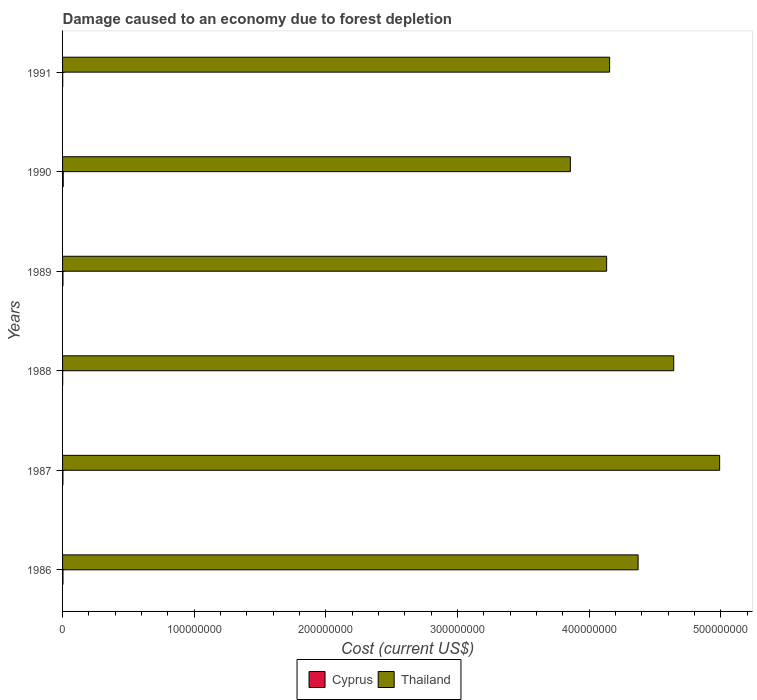How many different coloured bars are there?
Keep it short and to the point. 2. Are the number of bars per tick equal to the number of legend labels?
Give a very brief answer. Yes. What is the label of the 1st group of bars from the top?
Offer a terse response. 1991. What is the cost of damage caused due to forest depletion in Thailand in 1988?
Your answer should be compact. 4.64e+08. Across all years, what is the maximum cost of damage caused due to forest depletion in Cyprus?
Provide a succinct answer. 5.16e+05. Across all years, what is the minimum cost of damage caused due to forest depletion in Thailand?
Give a very brief answer. 3.86e+08. What is the total cost of damage caused due to forest depletion in Cyprus in the graph?
Keep it short and to the point. 1.59e+06. What is the difference between the cost of damage caused due to forest depletion in Thailand in 1989 and that in 1990?
Offer a terse response. 2.75e+07. What is the difference between the cost of damage caused due to forest depletion in Cyprus in 1990 and the cost of damage caused due to forest depletion in Thailand in 1989?
Provide a succinct answer. -4.13e+08. What is the average cost of damage caused due to forest depletion in Thailand per year?
Your answer should be compact. 4.36e+08. In the year 1990, what is the difference between the cost of damage caused due to forest depletion in Thailand and cost of damage caused due to forest depletion in Cyprus?
Your response must be concise. 3.85e+08. What is the ratio of the cost of damage caused due to forest depletion in Cyprus in 1989 to that in 1991?
Your answer should be very brief. 3.01. Is the cost of damage caused due to forest depletion in Cyprus in 1987 less than that in 1988?
Offer a very short reply. No. What is the difference between the highest and the second highest cost of damage caused due to forest depletion in Cyprus?
Make the answer very short. 2.01e+05. What is the difference between the highest and the lowest cost of damage caused due to forest depletion in Cyprus?
Offer a very short reply. 4.30e+05. In how many years, is the cost of damage caused due to forest depletion in Cyprus greater than the average cost of damage caused due to forest depletion in Cyprus taken over all years?
Offer a terse response. 4. What does the 2nd bar from the top in 1986 represents?
Ensure brevity in your answer.  Cyprus. What does the 2nd bar from the bottom in 1987 represents?
Your response must be concise. Thailand. How many bars are there?
Provide a succinct answer. 12. Are the values on the major ticks of X-axis written in scientific E-notation?
Offer a terse response. No. Does the graph contain any zero values?
Keep it short and to the point. No. How many legend labels are there?
Provide a succinct answer. 2. How are the legend labels stacked?
Make the answer very short. Horizontal. What is the title of the graph?
Your answer should be very brief. Damage caused to an economy due to forest depletion. What is the label or title of the X-axis?
Ensure brevity in your answer.  Cost (current US$). What is the Cost (current US$) in Cyprus in 1986?
Ensure brevity in your answer.  3.14e+05. What is the Cost (current US$) of Thailand in 1986?
Provide a succinct answer. 4.37e+08. What is the Cost (current US$) in Cyprus in 1987?
Provide a succinct answer. 2.67e+05. What is the Cost (current US$) in Thailand in 1987?
Your answer should be very brief. 4.99e+08. What is the Cost (current US$) of Cyprus in 1988?
Your answer should be compact. 8.51e+04. What is the Cost (current US$) of Thailand in 1988?
Offer a very short reply. 4.64e+08. What is the Cost (current US$) in Cyprus in 1989?
Make the answer very short. 3.10e+05. What is the Cost (current US$) of Thailand in 1989?
Provide a short and direct response. 4.13e+08. What is the Cost (current US$) in Cyprus in 1990?
Your answer should be very brief. 5.16e+05. What is the Cost (current US$) in Thailand in 1990?
Your response must be concise. 3.86e+08. What is the Cost (current US$) of Cyprus in 1991?
Your answer should be compact. 1.03e+05. What is the Cost (current US$) of Thailand in 1991?
Ensure brevity in your answer.  4.16e+08. Across all years, what is the maximum Cost (current US$) in Cyprus?
Give a very brief answer. 5.16e+05. Across all years, what is the maximum Cost (current US$) of Thailand?
Make the answer very short. 4.99e+08. Across all years, what is the minimum Cost (current US$) in Cyprus?
Offer a very short reply. 8.51e+04. Across all years, what is the minimum Cost (current US$) of Thailand?
Ensure brevity in your answer.  3.86e+08. What is the total Cost (current US$) in Cyprus in the graph?
Offer a terse response. 1.59e+06. What is the total Cost (current US$) of Thailand in the graph?
Make the answer very short. 2.62e+09. What is the difference between the Cost (current US$) of Cyprus in 1986 and that in 1987?
Offer a very short reply. 4.73e+04. What is the difference between the Cost (current US$) in Thailand in 1986 and that in 1987?
Your response must be concise. -6.19e+07. What is the difference between the Cost (current US$) in Cyprus in 1986 and that in 1988?
Your answer should be compact. 2.29e+05. What is the difference between the Cost (current US$) in Thailand in 1986 and that in 1988?
Give a very brief answer. -2.71e+07. What is the difference between the Cost (current US$) of Cyprus in 1986 and that in 1989?
Offer a terse response. 4549.1. What is the difference between the Cost (current US$) of Thailand in 1986 and that in 1989?
Make the answer very short. 2.39e+07. What is the difference between the Cost (current US$) of Cyprus in 1986 and that in 1990?
Provide a short and direct response. -2.01e+05. What is the difference between the Cost (current US$) of Thailand in 1986 and that in 1990?
Your answer should be very brief. 5.15e+07. What is the difference between the Cost (current US$) in Cyprus in 1986 and that in 1991?
Your response must be concise. 2.11e+05. What is the difference between the Cost (current US$) of Thailand in 1986 and that in 1991?
Offer a terse response. 2.16e+07. What is the difference between the Cost (current US$) in Cyprus in 1987 and that in 1988?
Your response must be concise. 1.82e+05. What is the difference between the Cost (current US$) in Thailand in 1987 and that in 1988?
Your response must be concise. 3.49e+07. What is the difference between the Cost (current US$) of Cyprus in 1987 and that in 1989?
Offer a terse response. -4.28e+04. What is the difference between the Cost (current US$) in Thailand in 1987 and that in 1989?
Ensure brevity in your answer.  8.58e+07. What is the difference between the Cost (current US$) of Cyprus in 1987 and that in 1990?
Your answer should be compact. -2.49e+05. What is the difference between the Cost (current US$) of Thailand in 1987 and that in 1990?
Your answer should be very brief. 1.13e+08. What is the difference between the Cost (current US$) in Cyprus in 1987 and that in 1991?
Provide a succinct answer. 1.64e+05. What is the difference between the Cost (current US$) of Thailand in 1987 and that in 1991?
Offer a terse response. 8.36e+07. What is the difference between the Cost (current US$) of Cyprus in 1988 and that in 1989?
Provide a succinct answer. -2.24e+05. What is the difference between the Cost (current US$) in Thailand in 1988 and that in 1989?
Provide a short and direct response. 5.10e+07. What is the difference between the Cost (current US$) in Cyprus in 1988 and that in 1990?
Offer a terse response. -4.30e+05. What is the difference between the Cost (current US$) in Thailand in 1988 and that in 1990?
Your response must be concise. 7.85e+07. What is the difference between the Cost (current US$) in Cyprus in 1988 and that in 1991?
Your answer should be very brief. -1.78e+04. What is the difference between the Cost (current US$) of Thailand in 1988 and that in 1991?
Keep it short and to the point. 4.87e+07. What is the difference between the Cost (current US$) in Cyprus in 1989 and that in 1990?
Offer a very short reply. -2.06e+05. What is the difference between the Cost (current US$) in Thailand in 1989 and that in 1990?
Your answer should be very brief. 2.75e+07. What is the difference between the Cost (current US$) in Cyprus in 1989 and that in 1991?
Give a very brief answer. 2.07e+05. What is the difference between the Cost (current US$) of Thailand in 1989 and that in 1991?
Your response must be concise. -2.27e+06. What is the difference between the Cost (current US$) of Cyprus in 1990 and that in 1991?
Your answer should be compact. 4.13e+05. What is the difference between the Cost (current US$) of Thailand in 1990 and that in 1991?
Give a very brief answer. -2.98e+07. What is the difference between the Cost (current US$) of Cyprus in 1986 and the Cost (current US$) of Thailand in 1987?
Your answer should be compact. -4.99e+08. What is the difference between the Cost (current US$) in Cyprus in 1986 and the Cost (current US$) in Thailand in 1988?
Offer a very short reply. -4.64e+08. What is the difference between the Cost (current US$) in Cyprus in 1986 and the Cost (current US$) in Thailand in 1989?
Offer a terse response. -4.13e+08. What is the difference between the Cost (current US$) in Cyprus in 1986 and the Cost (current US$) in Thailand in 1990?
Ensure brevity in your answer.  -3.85e+08. What is the difference between the Cost (current US$) of Cyprus in 1986 and the Cost (current US$) of Thailand in 1991?
Offer a terse response. -4.15e+08. What is the difference between the Cost (current US$) of Cyprus in 1987 and the Cost (current US$) of Thailand in 1988?
Keep it short and to the point. -4.64e+08. What is the difference between the Cost (current US$) in Cyprus in 1987 and the Cost (current US$) in Thailand in 1989?
Make the answer very short. -4.13e+08. What is the difference between the Cost (current US$) in Cyprus in 1987 and the Cost (current US$) in Thailand in 1990?
Your answer should be compact. -3.85e+08. What is the difference between the Cost (current US$) of Cyprus in 1987 and the Cost (current US$) of Thailand in 1991?
Your answer should be compact. -4.15e+08. What is the difference between the Cost (current US$) of Cyprus in 1988 and the Cost (current US$) of Thailand in 1989?
Make the answer very short. -4.13e+08. What is the difference between the Cost (current US$) in Cyprus in 1988 and the Cost (current US$) in Thailand in 1990?
Offer a very short reply. -3.86e+08. What is the difference between the Cost (current US$) in Cyprus in 1988 and the Cost (current US$) in Thailand in 1991?
Keep it short and to the point. -4.15e+08. What is the difference between the Cost (current US$) in Cyprus in 1989 and the Cost (current US$) in Thailand in 1990?
Your answer should be very brief. -3.85e+08. What is the difference between the Cost (current US$) of Cyprus in 1989 and the Cost (current US$) of Thailand in 1991?
Your response must be concise. -4.15e+08. What is the difference between the Cost (current US$) in Cyprus in 1990 and the Cost (current US$) in Thailand in 1991?
Provide a succinct answer. -4.15e+08. What is the average Cost (current US$) of Cyprus per year?
Your answer should be compact. 2.66e+05. What is the average Cost (current US$) in Thailand per year?
Provide a succinct answer. 4.36e+08. In the year 1986, what is the difference between the Cost (current US$) in Cyprus and Cost (current US$) in Thailand?
Keep it short and to the point. -4.37e+08. In the year 1987, what is the difference between the Cost (current US$) in Cyprus and Cost (current US$) in Thailand?
Your response must be concise. -4.99e+08. In the year 1988, what is the difference between the Cost (current US$) in Cyprus and Cost (current US$) in Thailand?
Offer a terse response. -4.64e+08. In the year 1989, what is the difference between the Cost (current US$) in Cyprus and Cost (current US$) in Thailand?
Keep it short and to the point. -4.13e+08. In the year 1990, what is the difference between the Cost (current US$) in Cyprus and Cost (current US$) in Thailand?
Keep it short and to the point. -3.85e+08. In the year 1991, what is the difference between the Cost (current US$) in Cyprus and Cost (current US$) in Thailand?
Provide a succinct answer. -4.15e+08. What is the ratio of the Cost (current US$) of Cyprus in 1986 to that in 1987?
Your response must be concise. 1.18. What is the ratio of the Cost (current US$) in Thailand in 1986 to that in 1987?
Provide a short and direct response. 0.88. What is the ratio of the Cost (current US$) in Cyprus in 1986 to that in 1988?
Offer a terse response. 3.69. What is the ratio of the Cost (current US$) of Thailand in 1986 to that in 1988?
Ensure brevity in your answer.  0.94. What is the ratio of the Cost (current US$) in Cyprus in 1986 to that in 1989?
Provide a succinct answer. 1.01. What is the ratio of the Cost (current US$) of Thailand in 1986 to that in 1989?
Your response must be concise. 1.06. What is the ratio of the Cost (current US$) in Cyprus in 1986 to that in 1990?
Your answer should be compact. 0.61. What is the ratio of the Cost (current US$) of Thailand in 1986 to that in 1990?
Ensure brevity in your answer.  1.13. What is the ratio of the Cost (current US$) of Cyprus in 1986 to that in 1991?
Provide a short and direct response. 3.05. What is the ratio of the Cost (current US$) in Thailand in 1986 to that in 1991?
Your response must be concise. 1.05. What is the ratio of the Cost (current US$) of Cyprus in 1987 to that in 1988?
Provide a succinct answer. 3.13. What is the ratio of the Cost (current US$) of Thailand in 1987 to that in 1988?
Provide a short and direct response. 1.08. What is the ratio of the Cost (current US$) of Cyprus in 1987 to that in 1989?
Ensure brevity in your answer.  0.86. What is the ratio of the Cost (current US$) of Thailand in 1987 to that in 1989?
Ensure brevity in your answer.  1.21. What is the ratio of the Cost (current US$) in Cyprus in 1987 to that in 1990?
Give a very brief answer. 0.52. What is the ratio of the Cost (current US$) in Thailand in 1987 to that in 1990?
Your answer should be compact. 1.29. What is the ratio of the Cost (current US$) in Cyprus in 1987 to that in 1991?
Provide a succinct answer. 2.59. What is the ratio of the Cost (current US$) of Thailand in 1987 to that in 1991?
Provide a short and direct response. 1.2. What is the ratio of the Cost (current US$) of Cyprus in 1988 to that in 1989?
Provide a short and direct response. 0.28. What is the ratio of the Cost (current US$) of Thailand in 1988 to that in 1989?
Your answer should be very brief. 1.12. What is the ratio of the Cost (current US$) in Cyprus in 1988 to that in 1990?
Give a very brief answer. 0.17. What is the ratio of the Cost (current US$) of Thailand in 1988 to that in 1990?
Give a very brief answer. 1.2. What is the ratio of the Cost (current US$) in Cyprus in 1988 to that in 1991?
Your response must be concise. 0.83. What is the ratio of the Cost (current US$) of Thailand in 1988 to that in 1991?
Your answer should be very brief. 1.12. What is the ratio of the Cost (current US$) in Cyprus in 1989 to that in 1990?
Offer a terse response. 0.6. What is the ratio of the Cost (current US$) in Thailand in 1989 to that in 1990?
Keep it short and to the point. 1.07. What is the ratio of the Cost (current US$) of Cyprus in 1989 to that in 1991?
Your answer should be very brief. 3.01. What is the ratio of the Cost (current US$) of Thailand in 1989 to that in 1991?
Give a very brief answer. 0.99. What is the ratio of the Cost (current US$) of Cyprus in 1990 to that in 1991?
Your response must be concise. 5.01. What is the ratio of the Cost (current US$) of Thailand in 1990 to that in 1991?
Keep it short and to the point. 0.93. What is the difference between the highest and the second highest Cost (current US$) in Cyprus?
Give a very brief answer. 2.01e+05. What is the difference between the highest and the second highest Cost (current US$) in Thailand?
Your answer should be compact. 3.49e+07. What is the difference between the highest and the lowest Cost (current US$) of Cyprus?
Provide a succinct answer. 4.30e+05. What is the difference between the highest and the lowest Cost (current US$) of Thailand?
Offer a terse response. 1.13e+08. 